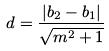Convert formula to latex. <formula><loc_0><loc_0><loc_500><loc_500>d = \frac { | b _ { 2 } - b _ { 1 } | } { \sqrt { m ^ { 2 } + 1 } }</formula> 